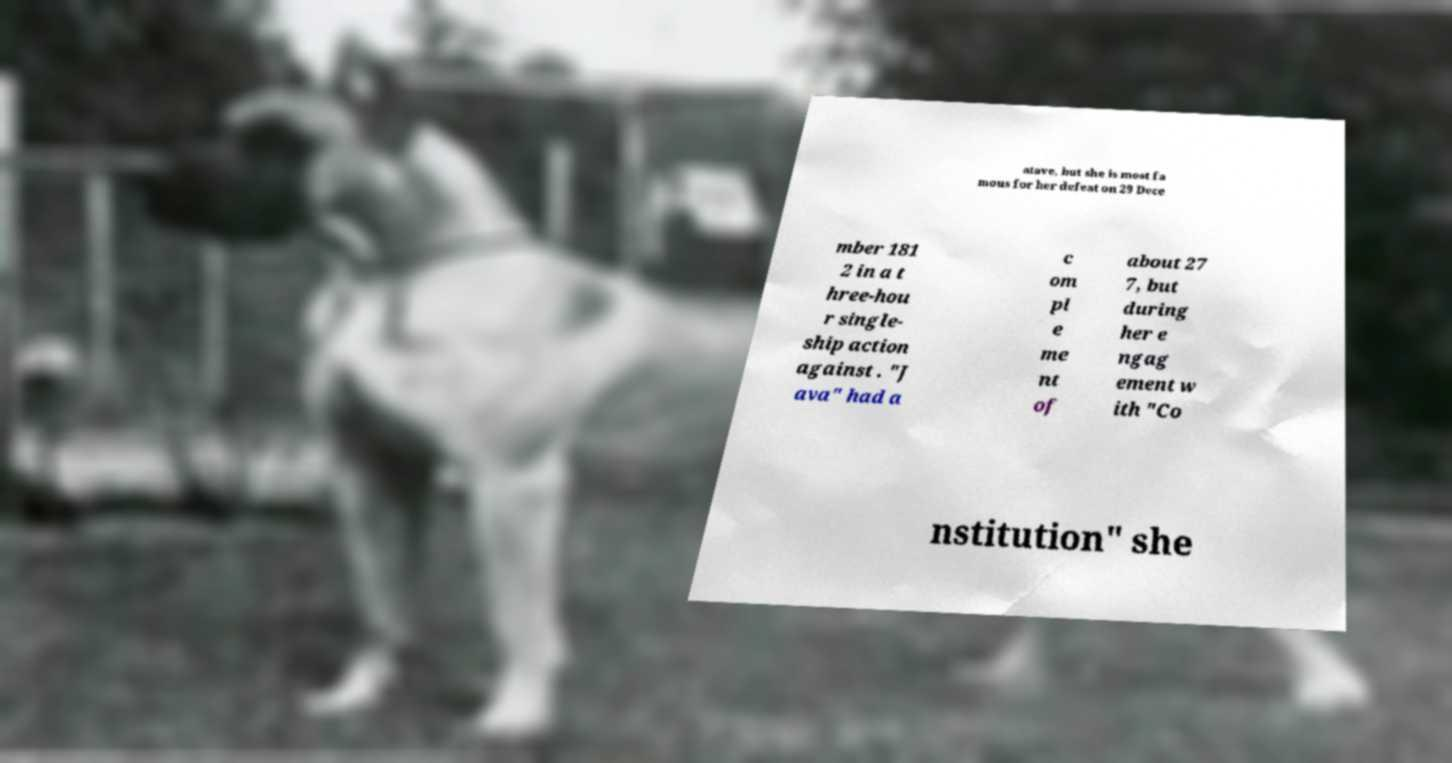For documentation purposes, I need the text within this image transcribed. Could you provide that? atave, but she is most fa mous for her defeat on 29 Dece mber 181 2 in a t hree-hou r single- ship action against . "J ava" had a c om pl e me nt of about 27 7, but during her e ngag ement w ith "Co nstitution" she 